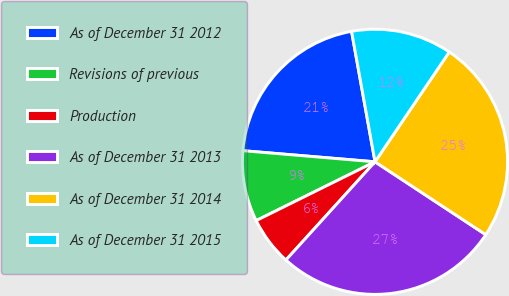Convert chart. <chart><loc_0><loc_0><loc_500><loc_500><pie_chart><fcel>As of December 31 2012<fcel>Revisions of previous<fcel>Production<fcel>As of December 31 2013<fcel>As of December 31 2014<fcel>As of December 31 2015<nl><fcel>20.83%<fcel>8.65%<fcel>5.96%<fcel>27.46%<fcel>24.8%<fcel>12.29%<nl></chart> 